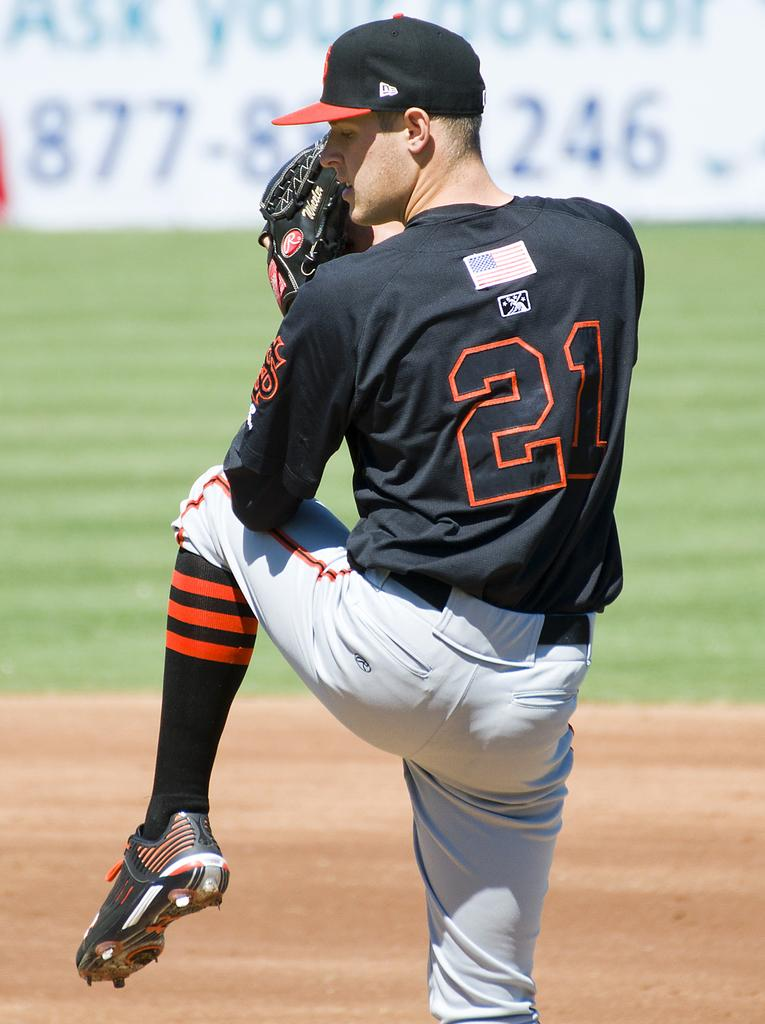<image>
Write a terse but informative summary of the picture. A pitcher is winding up to throw the ball and a sign behind him says Ask Your Doctor. 